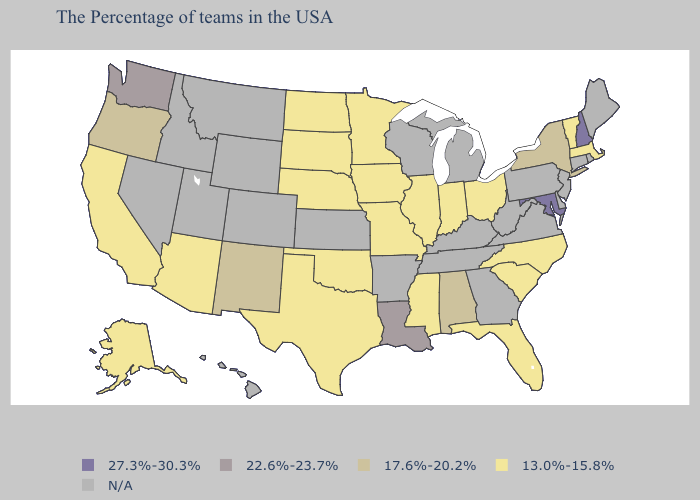What is the lowest value in the South?
Answer briefly. 13.0%-15.8%. Name the states that have a value in the range 27.3%-30.3%?
Quick response, please. New Hampshire, Maryland. What is the lowest value in the USA?
Give a very brief answer. 13.0%-15.8%. Does the map have missing data?
Be succinct. Yes. Which states have the highest value in the USA?
Short answer required. New Hampshire, Maryland. Name the states that have a value in the range 13.0%-15.8%?
Keep it brief. Massachusetts, Vermont, North Carolina, South Carolina, Ohio, Florida, Indiana, Illinois, Mississippi, Missouri, Minnesota, Iowa, Nebraska, Oklahoma, Texas, South Dakota, North Dakota, Arizona, California, Alaska. What is the highest value in states that border Delaware?
Give a very brief answer. 27.3%-30.3%. What is the lowest value in the USA?
Answer briefly. 13.0%-15.8%. Does Vermont have the lowest value in the Northeast?
Be succinct. Yes. Does Oregon have the highest value in the West?
Concise answer only. No. Name the states that have a value in the range 17.6%-20.2%?
Keep it brief. New York, Alabama, New Mexico, Oregon. What is the value of Mississippi?
Answer briefly. 13.0%-15.8%. Name the states that have a value in the range 27.3%-30.3%?
Give a very brief answer. New Hampshire, Maryland. Name the states that have a value in the range 22.6%-23.7%?
Concise answer only. Louisiana, Washington. Does the first symbol in the legend represent the smallest category?
Quick response, please. No. 